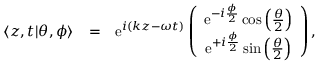Convert formula to latex. <formula><loc_0><loc_0><loc_500><loc_500>\begin{array} { r l r } { \langle z , t | \theta , \phi \rangle } & { = } & { e ^ { i ( k z - \omega t ) } \left ( \begin{array} { c } { e ^ { - i \frac { \phi } { 2 } } \cos \left ( \frac { \theta } { 2 } \right ) } \\ { e ^ { + i \frac { \phi } { 2 } } \sin \left ( \frac { \theta } { 2 } \right ) } \end{array} \right ) , } \end{array}</formula> 